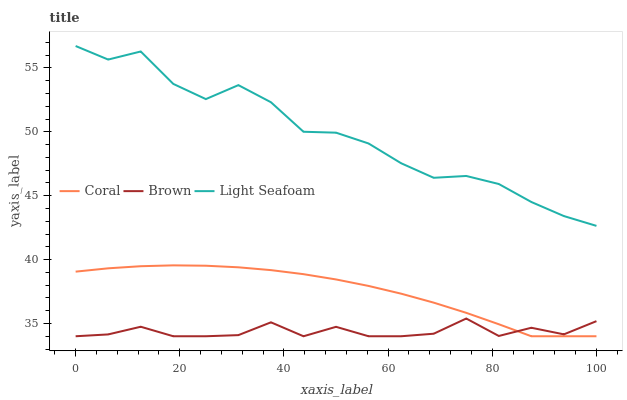Does Brown have the minimum area under the curve?
Answer yes or no. Yes. Does Light Seafoam have the maximum area under the curve?
Answer yes or no. Yes. Does Coral have the minimum area under the curve?
Answer yes or no. No. Does Coral have the maximum area under the curve?
Answer yes or no. No. Is Coral the smoothest?
Answer yes or no. Yes. Is Light Seafoam the roughest?
Answer yes or no. Yes. Is Light Seafoam the smoothest?
Answer yes or no. No. Is Coral the roughest?
Answer yes or no. No. Does Brown have the lowest value?
Answer yes or no. Yes. Does Light Seafoam have the lowest value?
Answer yes or no. No. Does Light Seafoam have the highest value?
Answer yes or no. Yes. Does Coral have the highest value?
Answer yes or no. No. Is Brown less than Light Seafoam?
Answer yes or no. Yes. Is Light Seafoam greater than Coral?
Answer yes or no. Yes. Does Coral intersect Brown?
Answer yes or no. Yes. Is Coral less than Brown?
Answer yes or no. No. Is Coral greater than Brown?
Answer yes or no. No. Does Brown intersect Light Seafoam?
Answer yes or no. No. 